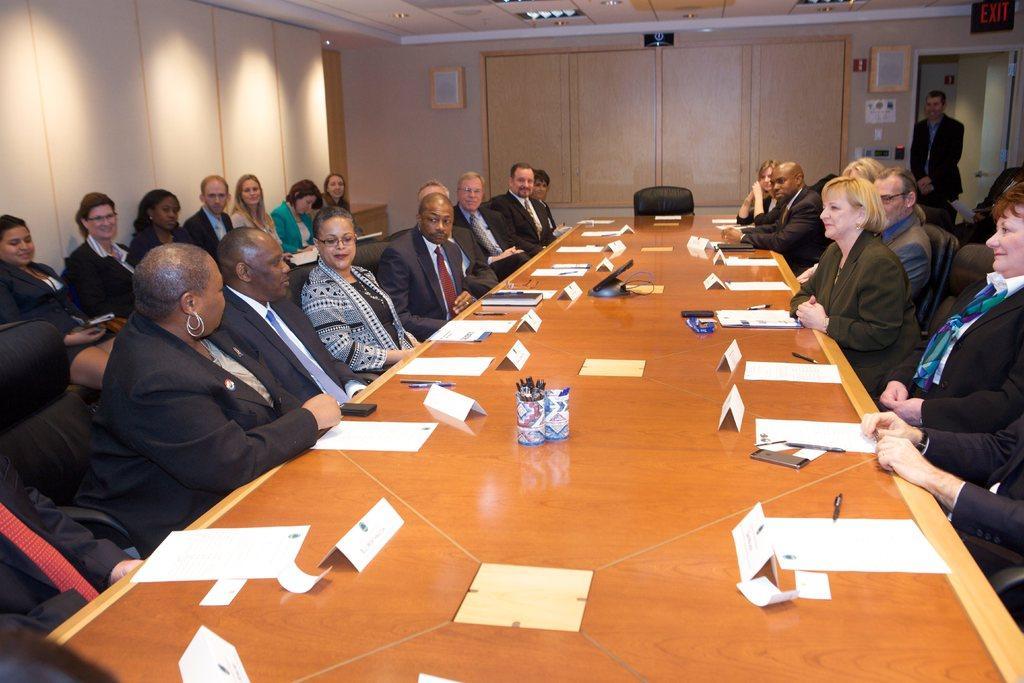In one or two sentences, can you explain what this image depicts? In this image I can see the group of people sitting and one person standing. I can see few people are sitting in-front of the table. On the table there are many papers, boards and the pens in the cup. In the background I can see the boards to the wall. 